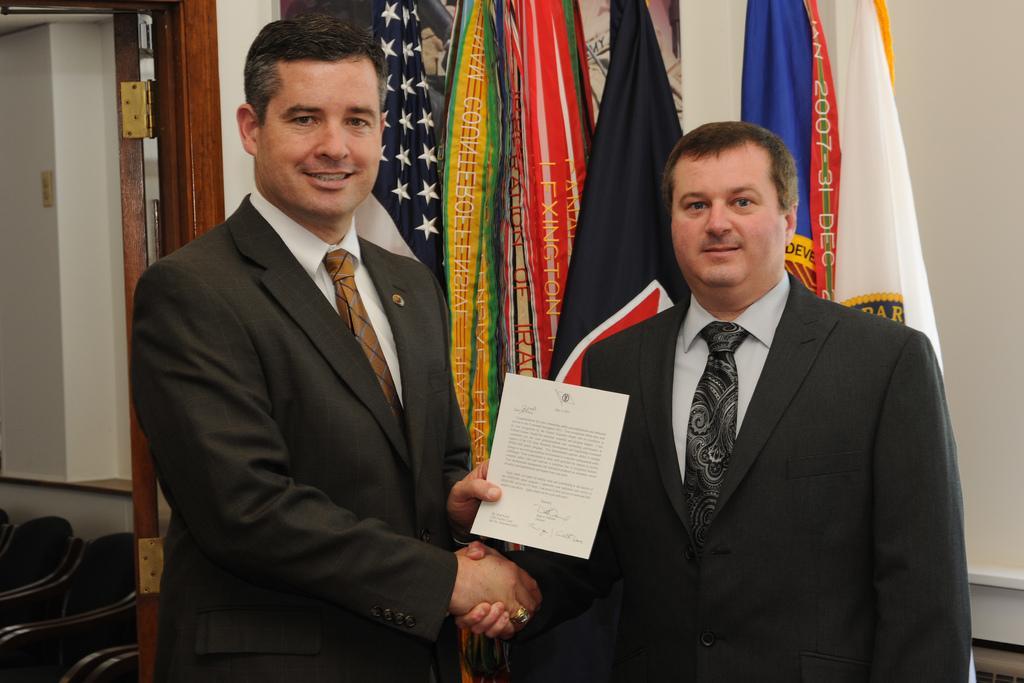Please provide a concise description of this image. In this picture we can observe two men shaking their hands. Both of them are smiling and wearing coats. One of them is holding a paper in his hand. Behind them there are some flags. In the background we can observe a door and a wall. 